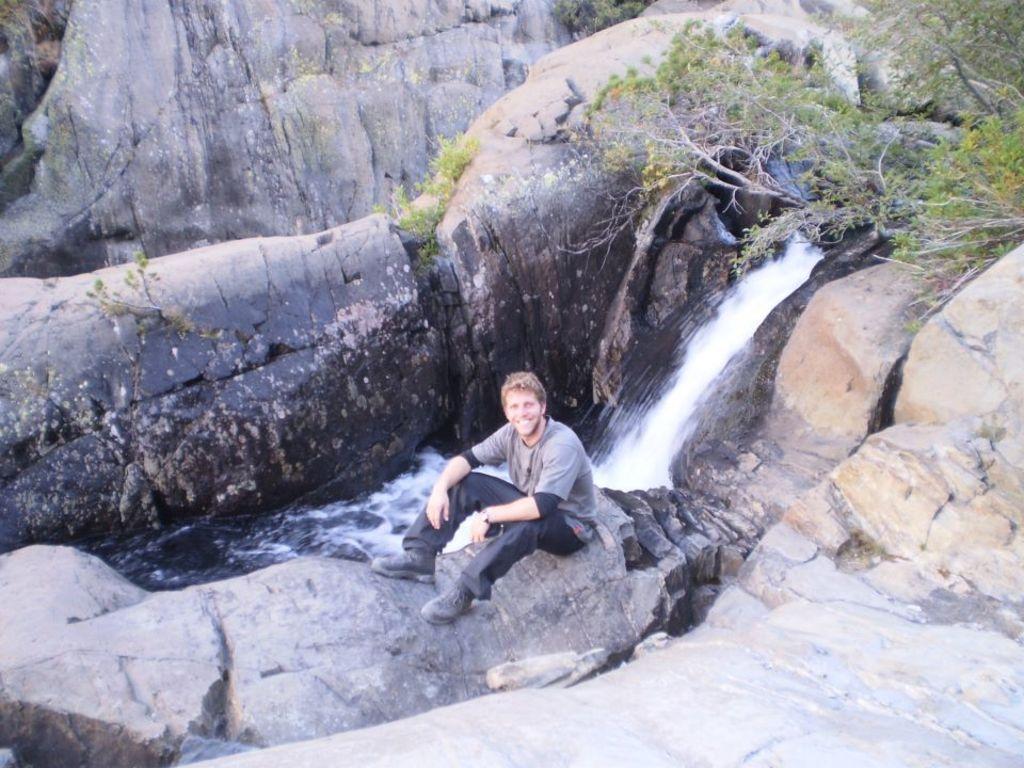Describe this image in one or two sentences. In this picture I can see a man sitting on the rock, in the middle there is the waterfall. On the right side there are trees. 